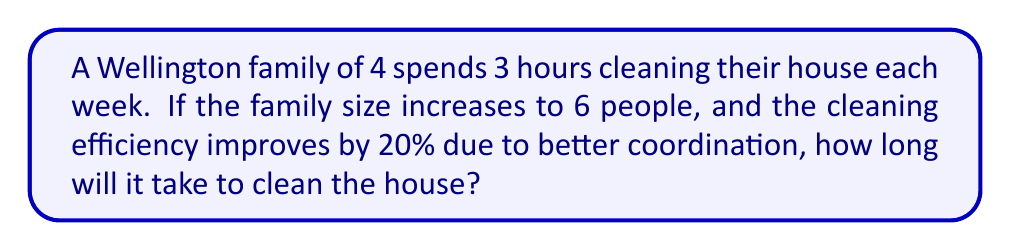Could you help me with this problem? Let's approach this step-by-step:

1. Set up the initial equation:
   Let $x$ be the time needed for the 6-person family to clean the house.
   $$\frac{4 \text{ people} \times 3 \text{ hours}}{6 \text{ people}} = 1.2x$$

   The left side represents the work done by the 4-person family, adjusted for the 6-person family.
   The right side represents the work done by the 6-person family with 20% improved efficiency.

2. Simplify the left side:
   $$2 = 1.2x$$

3. Solve for $x$:
   $$x = \frac{2}{1.2} = \frac{10}{6} = 1.6666...$$

4. Round to the nearest minute:
   1.6666... hours = 1 hour and 40 minutes
Answer: 1 hour and 40 minutes 